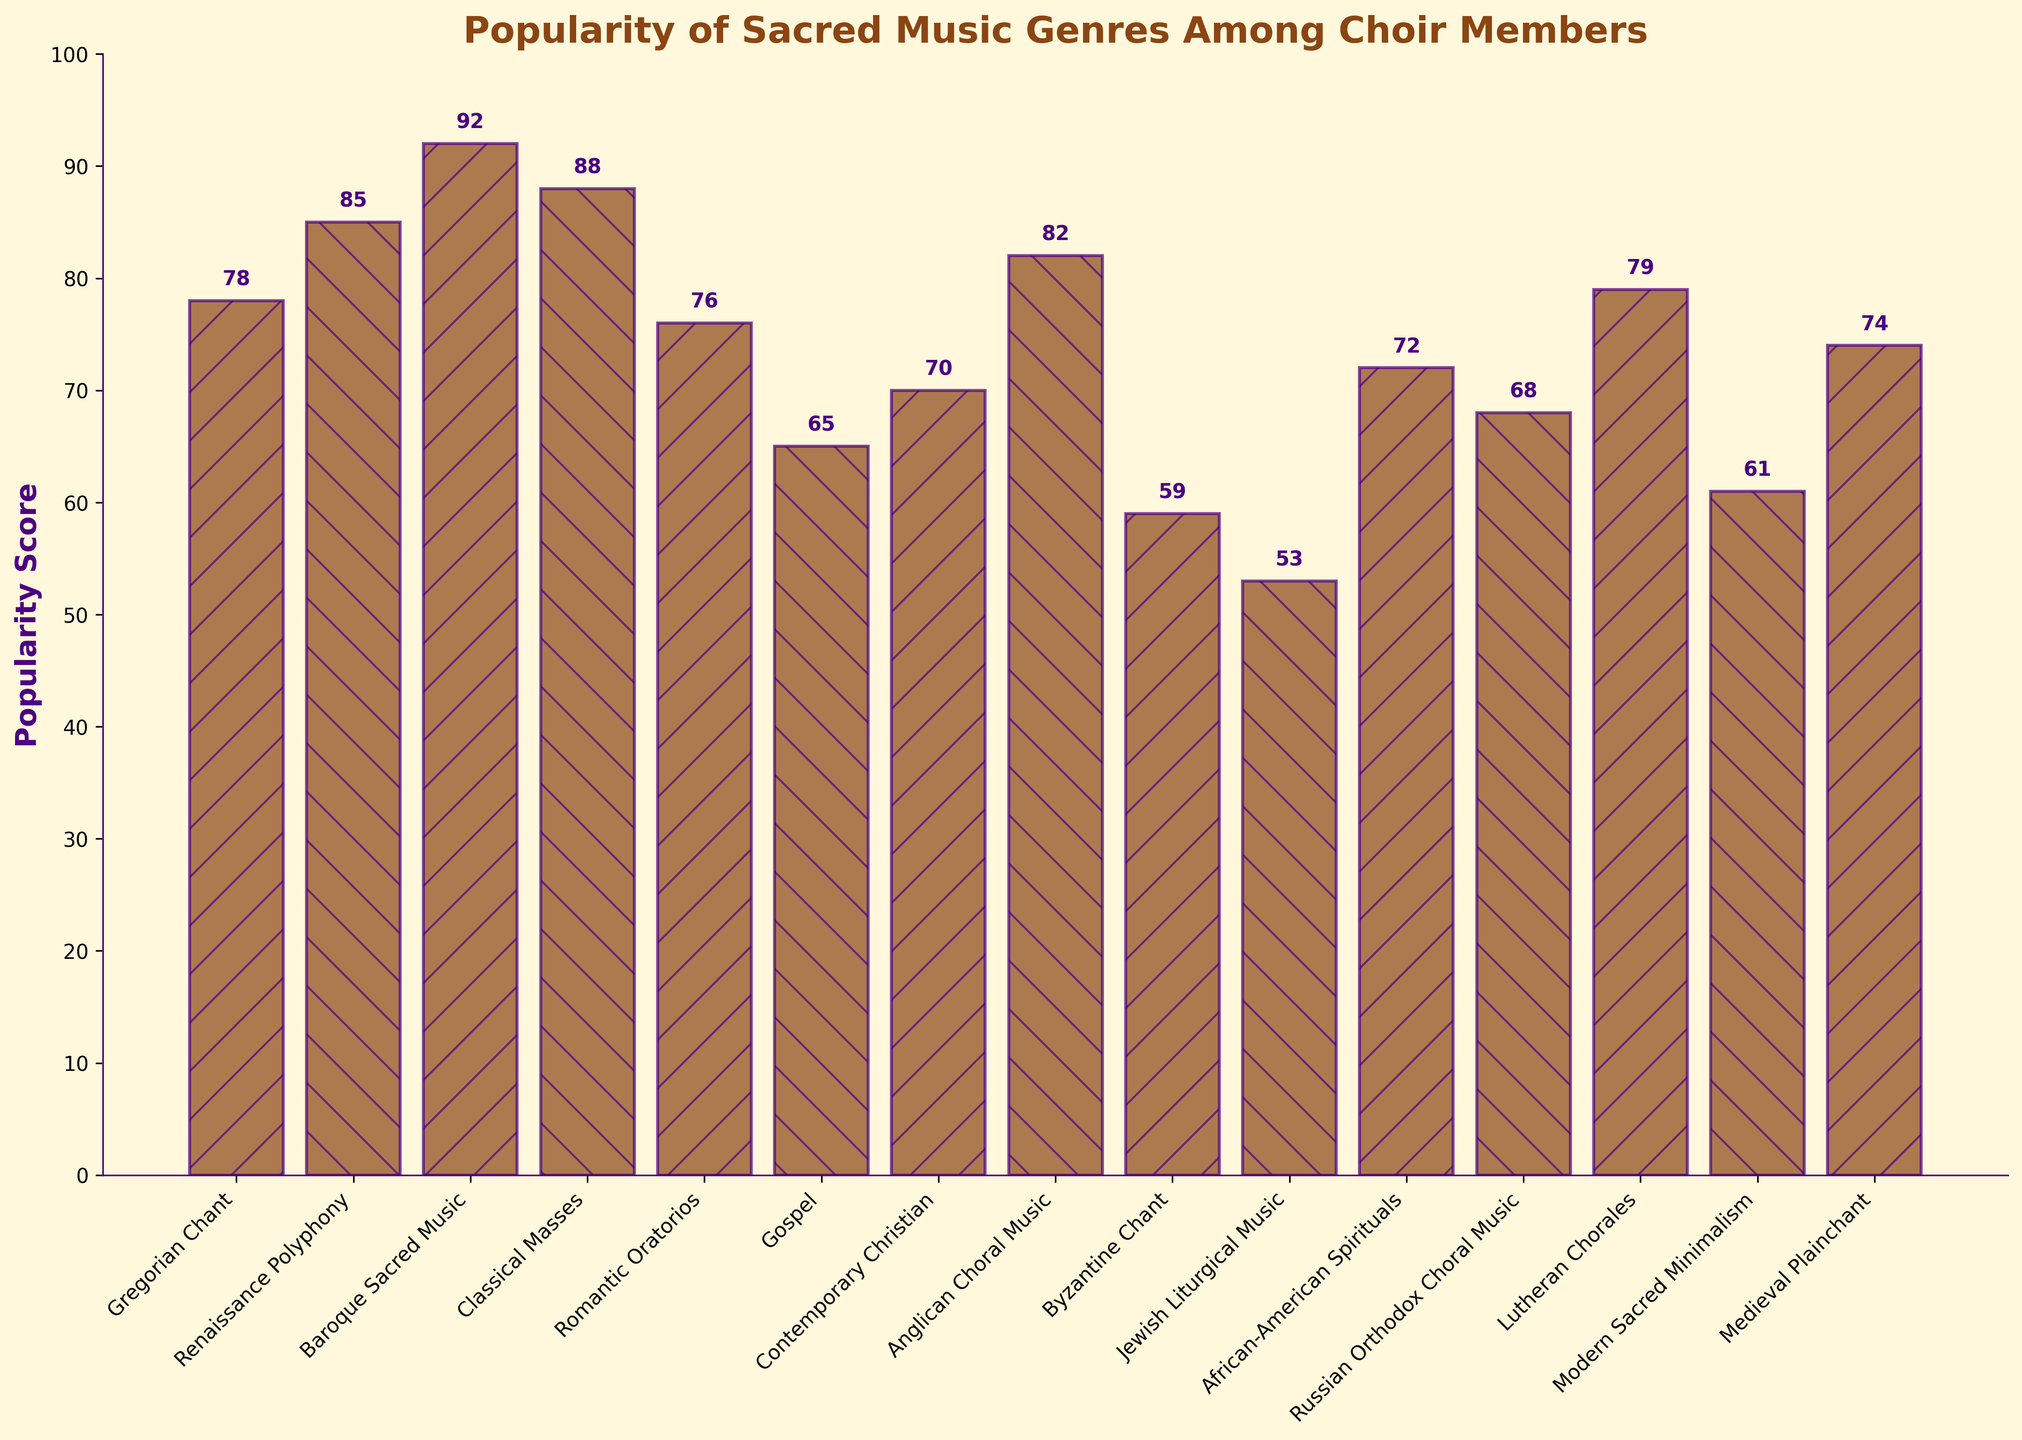What is the most popular sacred music genre among choir members? By observing the figure, the bar representing "Baroque Sacred Music" is the highest, indicating it has the highest popularity score.
Answer: Baroque Sacred Music Which sacred music genre has the least popularity among choir members? By looking at the shortest bar, "Jewish Liturgical Music" stands out with the lowest popularity score.
Answer: Jewish Liturgical Music How much higher is the popularity score of "Renaissance Polyphony" compared to "Modern Sacred Minimalism"? The popularity score of "Renaissance Polyphony" is 85, and the score for "Modern Sacred Minimalism" is 61. The difference is 85 - 61 = 24.
Answer: 24 Rank the top three most popular sacred music genres. The three tallest bars are "Baroque Sacred Music" (92), "Classical Masses" (88), and "Renaissance Polyphony" (85).
Answer: Baroque Sacred Music, Classical Masses, Renaissance Polyphony Is the popularity of "Contemporary Christian" more than "Anglican Choral Music"? The height of the bar for "Contemporary Christian" (70) is less than that of "Anglican Choral Music" (82), so "Contemporary Christian" is not more popular.
Answer: No What is the total popularity score for "Gospel" and "African-American Spirituals"? The popularity scores are 65 for "Gospel" and 72 for "African-American Spirituals". The sum is 65 + 72 = 137.
Answer: 137 How many genres have a popularity score greater than 80? The genres with scores above 80 are "Renaissance Polyphony" (85), "Baroque Sacred Music" (92), "Classical Masses" (88), and "Anglican Choral Music" (82). Counting these gives a total of 4 genres.
Answer: 4 What is the average popularity score of genres starting with the letter 'B'? The genres are "Baroque Sacred Music" (92) and "Byzantine Chant" (59). The average is (92 + 59) / 2 = 75.5.
Answer: 75.5 